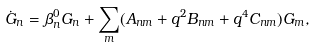Convert formula to latex. <formula><loc_0><loc_0><loc_500><loc_500>\dot { G } _ { n } = \beta _ { n } ^ { 0 } G _ { n } + \sum _ { m } ( A _ { n m } + q ^ { 2 } B _ { n m } + q ^ { 4 } C _ { n m } ) G _ { m } ,</formula> 